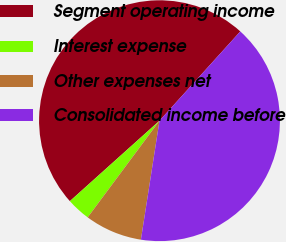Convert chart to OTSL. <chart><loc_0><loc_0><loc_500><loc_500><pie_chart><fcel>Segment operating income<fcel>Interest expense<fcel>Other expenses net<fcel>Consolidated income before<nl><fcel>48.35%<fcel>3.19%<fcel>7.7%<fcel>40.76%<nl></chart> 